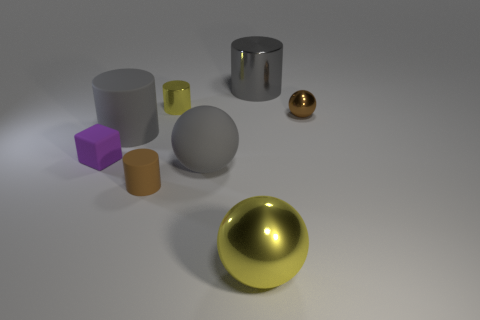How many small rubber things are the same color as the tiny metallic ball?
Give a very brief answer. 1. How many things are gray matte objects that are left of the tiny brown rubber cylinder or small objects behind the tiny metallic ball?
Make the answer very short. 2. What number of large yellow balls are in front of the small brown thing that is in front of the brown metallic thing?
Your answer should be very brief. 1. What color is the big cylinder that is made of the same material as the small brown cylinder?
Provide a short and direct response. Gray. Is there a cyan rubber sphere that has the same size as the gray metallic thing?
Your answer should be compact. No. There is a brown metallic thing that is the same size as the purple rubber object; what is its shape?
Ensure brevity in your answer.  Sphere. Are there any purple shiny things of the same shape as the small yellow metallic object?
Provide a succinct answer. No. Is the material of the small sphere the same as the brown thing in front of the purple block?
Give a very brief answer. No. Is there a large matte thing that has the same color as the large shiny cylinder?
Your response must be concise. Yes. How many other things are the same material as the tiny sphere?
Give a very brief answer. 3. 